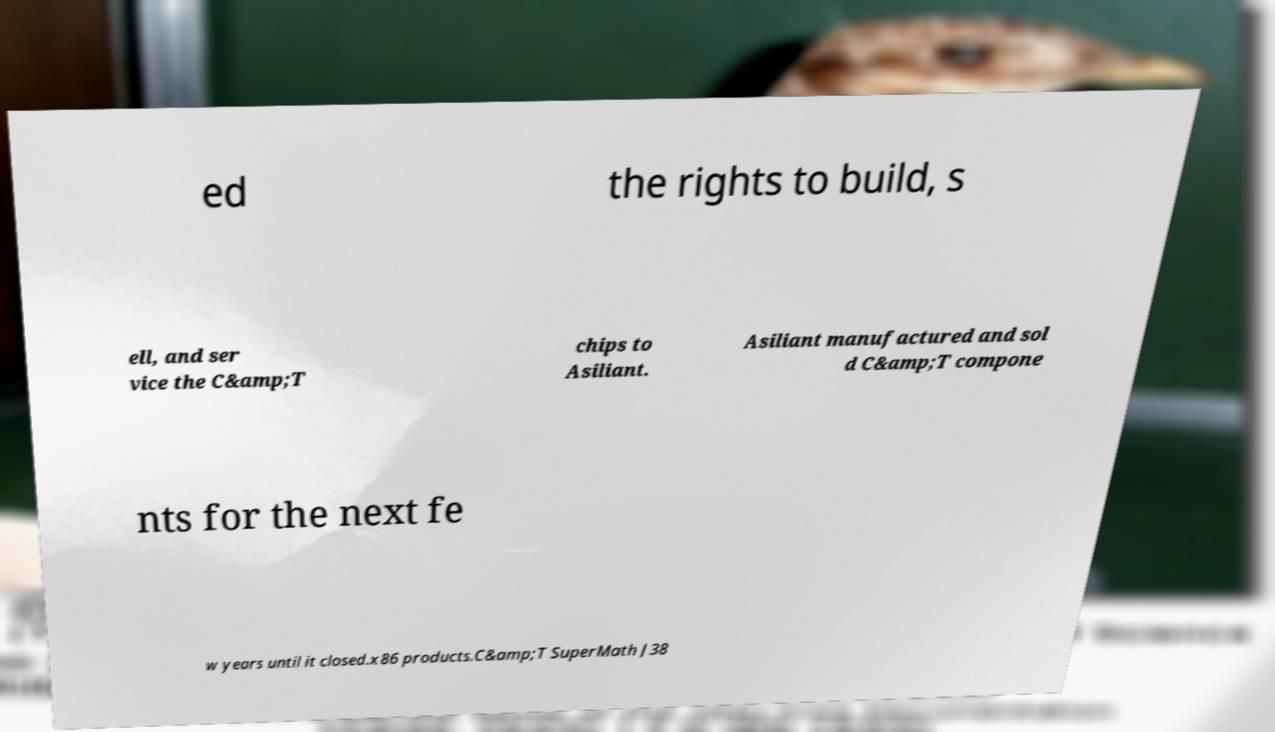Could you extract and type out the text from this image? ed the rights to build, s ell, and ser vice the C&amp;T chips to Asiliant. Asiliant manufactured and sol d C&amp;T compone nts for the next fe w years until it closed.x86 products.C&amp;T SuperMath J38 